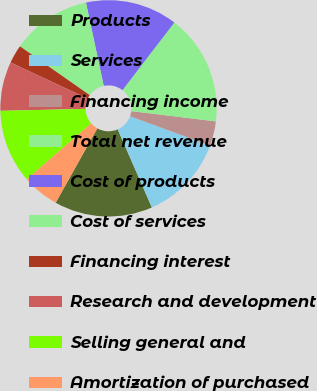<chart> <loc_0><loc_0><loc_500><loc_500><pie_chart><fcel>Products<fcel>Services<fcel>Financing income<fcel>Total net revenue<fcel>Cost of products<fcel>Cost of services<fcel>Financing interest<fcel>Research and development<fcel>Selling general and<fcel>Amortization of purchased<nl><fcel>14.68%<fcel>12.84%<fcel>3.67%<fcel>16.51%<fcel>13.76%<fcel>11.93%<fcel>2.75%<fcel>7.34%<fcel>11.01%<fcel>5.5%<nl></chart> 